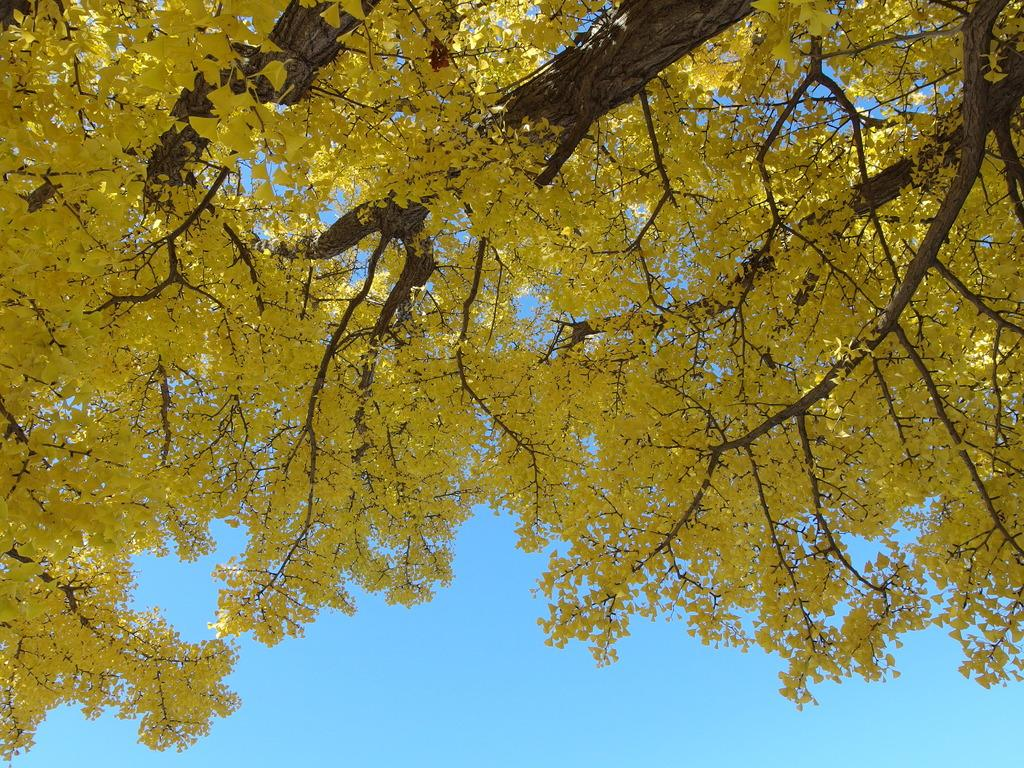What type of vegetation is in the front of the image? There are trees in the front of the image. What can be seen in the background of the image? The sky is visible in the background of the image. What color are the leaves on the trees? The leaves on the trees have a yellow color. What type of question is being asked by the hen in the image? There is no hen present in the image, so it is not possible to answer that question. 